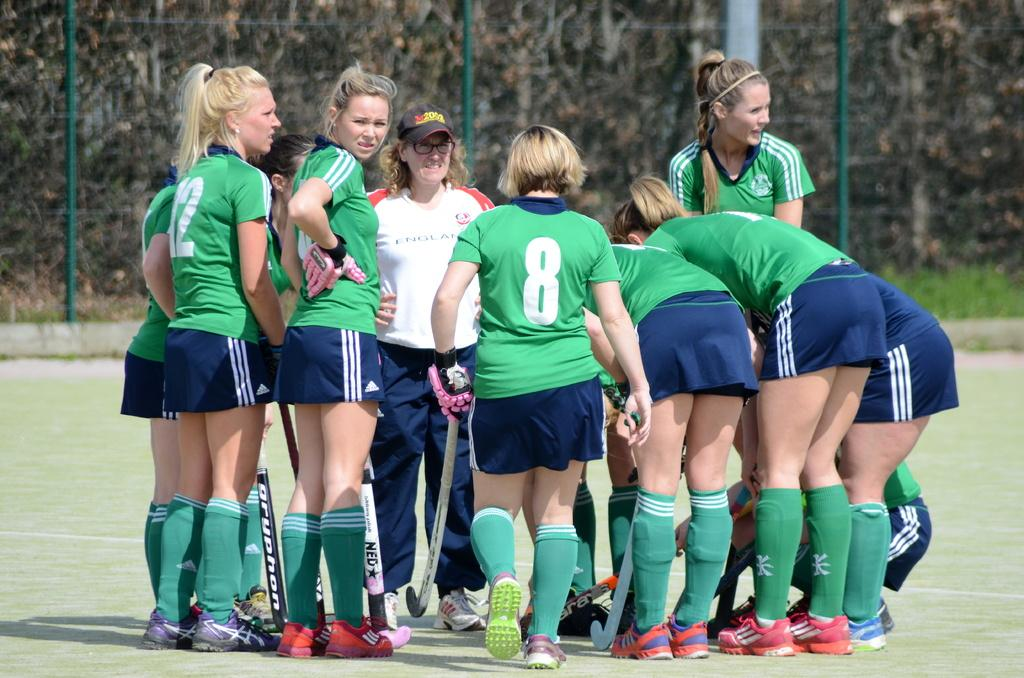<image>
Write a terse but informative summary of the picture. Player 8 walking up her other team member already in a group. 